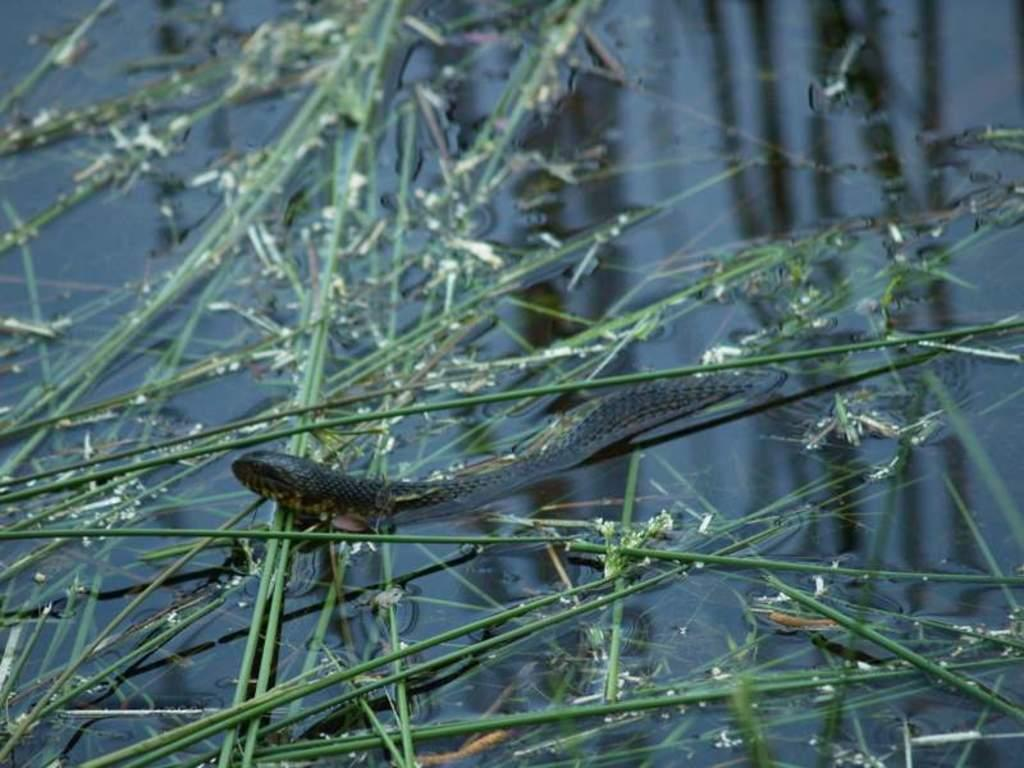What is in the water in the middle of the picture? There is a snake in the water in the middle of the picture. What else can be seen floating on the water? There is grass floating on the water. What type of yarn is being used to create the sheet in the image? There is no yarn or sheet present in the image; it features a snake in the water and grass floating on the water. 